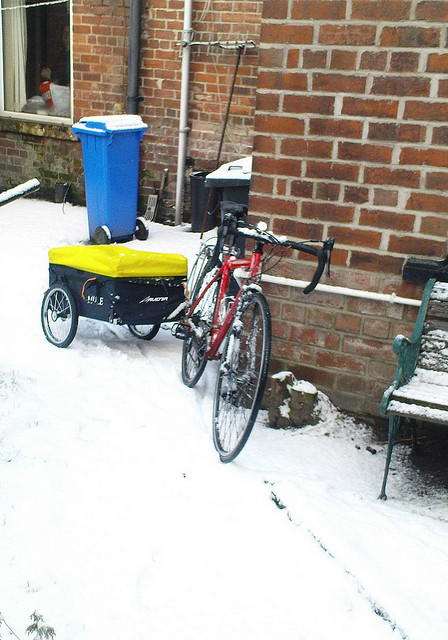<image>What kind of bike is in the picture? I don't know what kind of bike is in the picture. It might be a sports, 10 speed, street, men's, adult, standard, pedal or racing bike. What kind of bike is in the picture? I don't know what kind of bike is in the picture. It can be a bicycle, sports bike, 10 speed, street bike, or racing bike. 